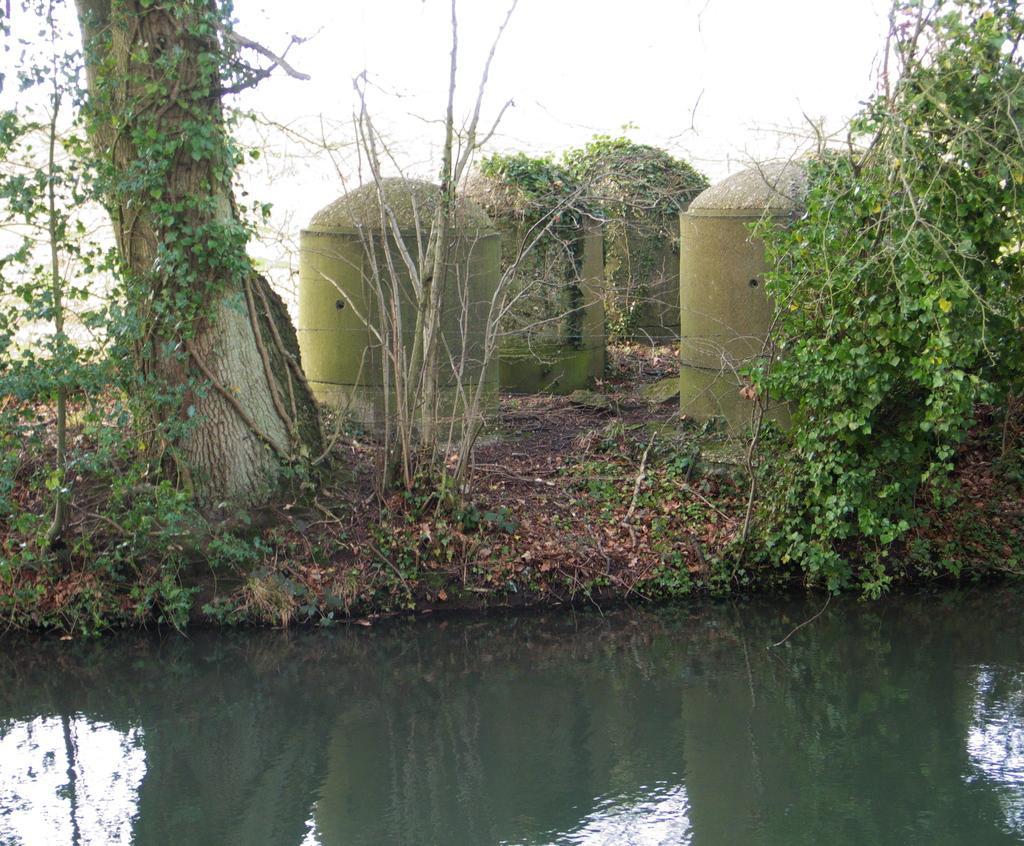Please provide a concise description of this image. In the center of the image there are pillars and there are trees. At the bottom there is water. In the background there is sky. 